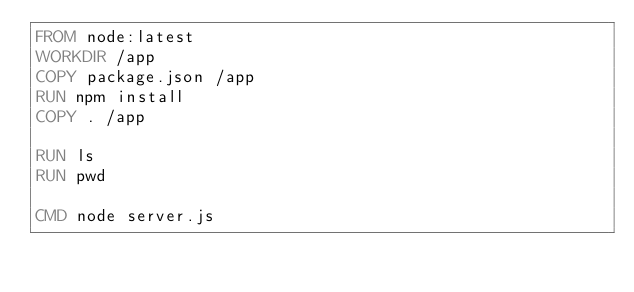Convert code to text. <code><loc_0><loc_0><loc_500><loc_500><_Dockerfile_>FROM node:latest
WORKDIR /app
COPY package.json /app
RUN npm install
COPY . /app

RUN ls
RUN pwd

CMD node server.js</code> 